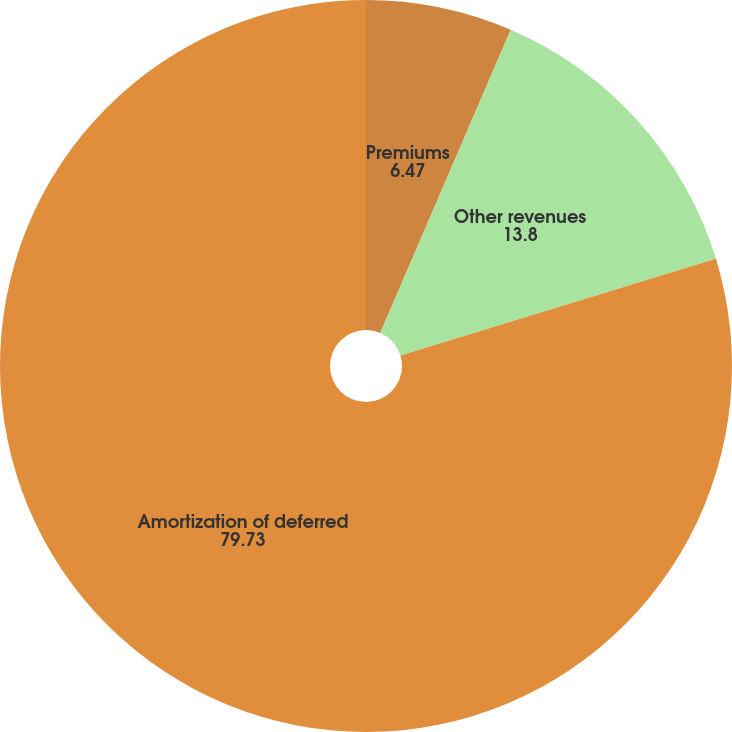Convert chart. <chart><loc_0><loc_0><loc_500><loc_500><pie_chart><fcel>Premiums<fcel>Other revenues<fcel>Amortization of deferred<nl><fcel>6.47%<fcel>13.8%<fcel>79.73%<nl></chart> 